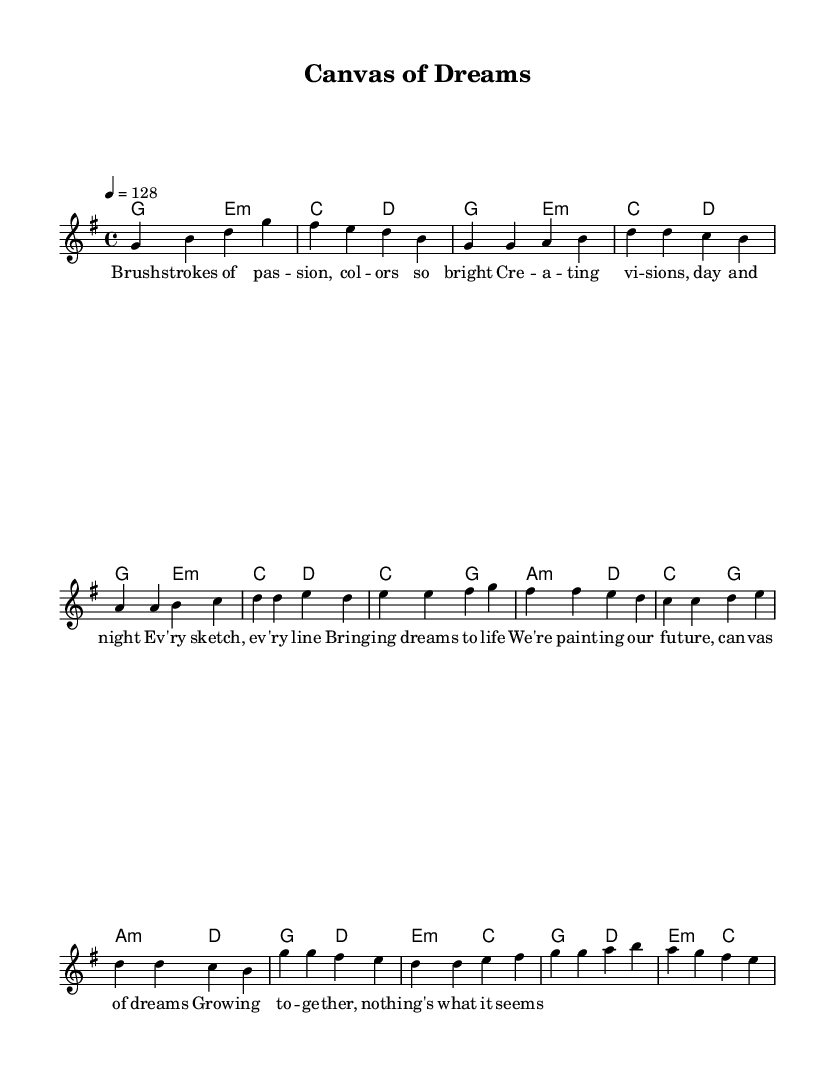What is the key signature of this music? The key signature indicates that the music is in G major, which has one sharp (F#). This is identified by looking at the key signature notation at the beginning of the score.
Answer: G major What is the time signature of the piece? The time signature shown near the beginning of the score is 4/4, which means there are four beats in a measure and the quarter note receives one beat. It is located at the beginning of the score next to the key signature.
Answer: 4/4 What is the tempo marking of this music? The tempo marking in the score shows that the piece should be played at a speed of 128 beats per minute. This information is found within the tempo directive symbol indicating the speed for the performance.
Answer: 128 How many sections does this piece have? Upon reviewing the structure of the piece, it can be noticed that it is divided into an Introduction, Verse, Pre-Chorus, and Chorus. Each section of the music is delineated in the notes and lyrics, showcasing its different parts.
Answer: 4 What emotion is primarily conveyed in the lyrics of the verse? Analyzing the lyrics of the verse, the predominant themes revolve around creativity and growth, suggesting a sense of optimism and inspiration. This can be inferred from phrases that discuss bringing dreams to life and painting the future.
Answer: Optimism What type of musical form is used in this K-Pop piece? The musical form of this piece is a verse-chorus structure, which is common in K-Pop. This can be identified through the repetition of melodic and lyrical themes after the introduction, in the verse and chorus sections.
Answer: Verse-Chorus What musical techniques are employed in the chorus of this piece? In the chorus, various techniques are utilized such as catchy melodic hooks and repetition which are designed to enhance memorability and allow for sing-along moments, which are characteristics typical in K-Pop music. This can be noted from the phrase constructions and rhythmic patterns used.
Answer: Catchy hooks 